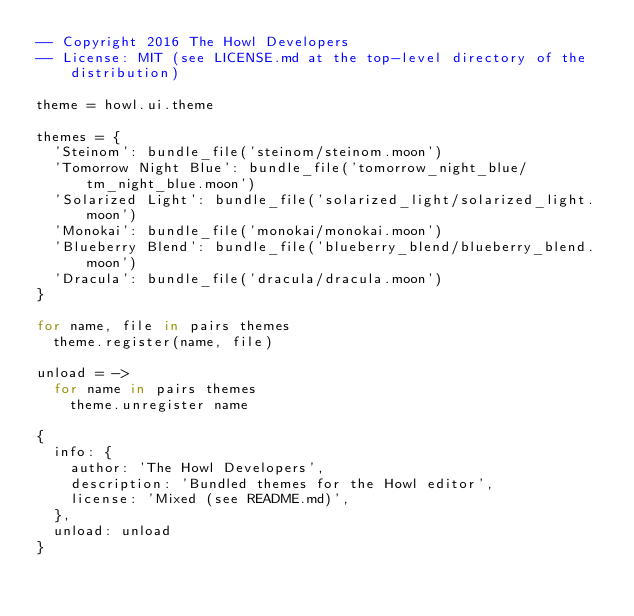<code> <loc_0><loc_0><loc_500><loc_500><_MoonScript_>-- Copyright 2016 The Howl Developers
-- License: MIT (see LICENSE.md at the top-level directory of the distribution)

theme = howl.ui.theme

themes = {
  'Steinom': bundle_file('steinom/steinom.moon')
  'Tomorrow Night Blue': bundle_file('tomorrow_night_blue/tm_night_blue.moon')
  'Solarized Light': bundle_file('solarized_light/solarized_light.moon')
  'Monokai': bundle_file('monokai/monokai.moon')
  'Blueberry Blend': bundle_file('blueberry_blend/blueberry_blend.moon')
  'Dracula': bundle_file('dracula/dracula.moon')
}

for name, file in pairs themes
  theme.register(name, file)

unload = ->
  for name in pairs themes
    theme.unregister name

{
  info: {
    author: 'The Howl Developers',
    description: 'Bundled themes for the Howl editor',
    license: 'Mixed (see README.md)',
  },
  unload: unload
}
</code> 